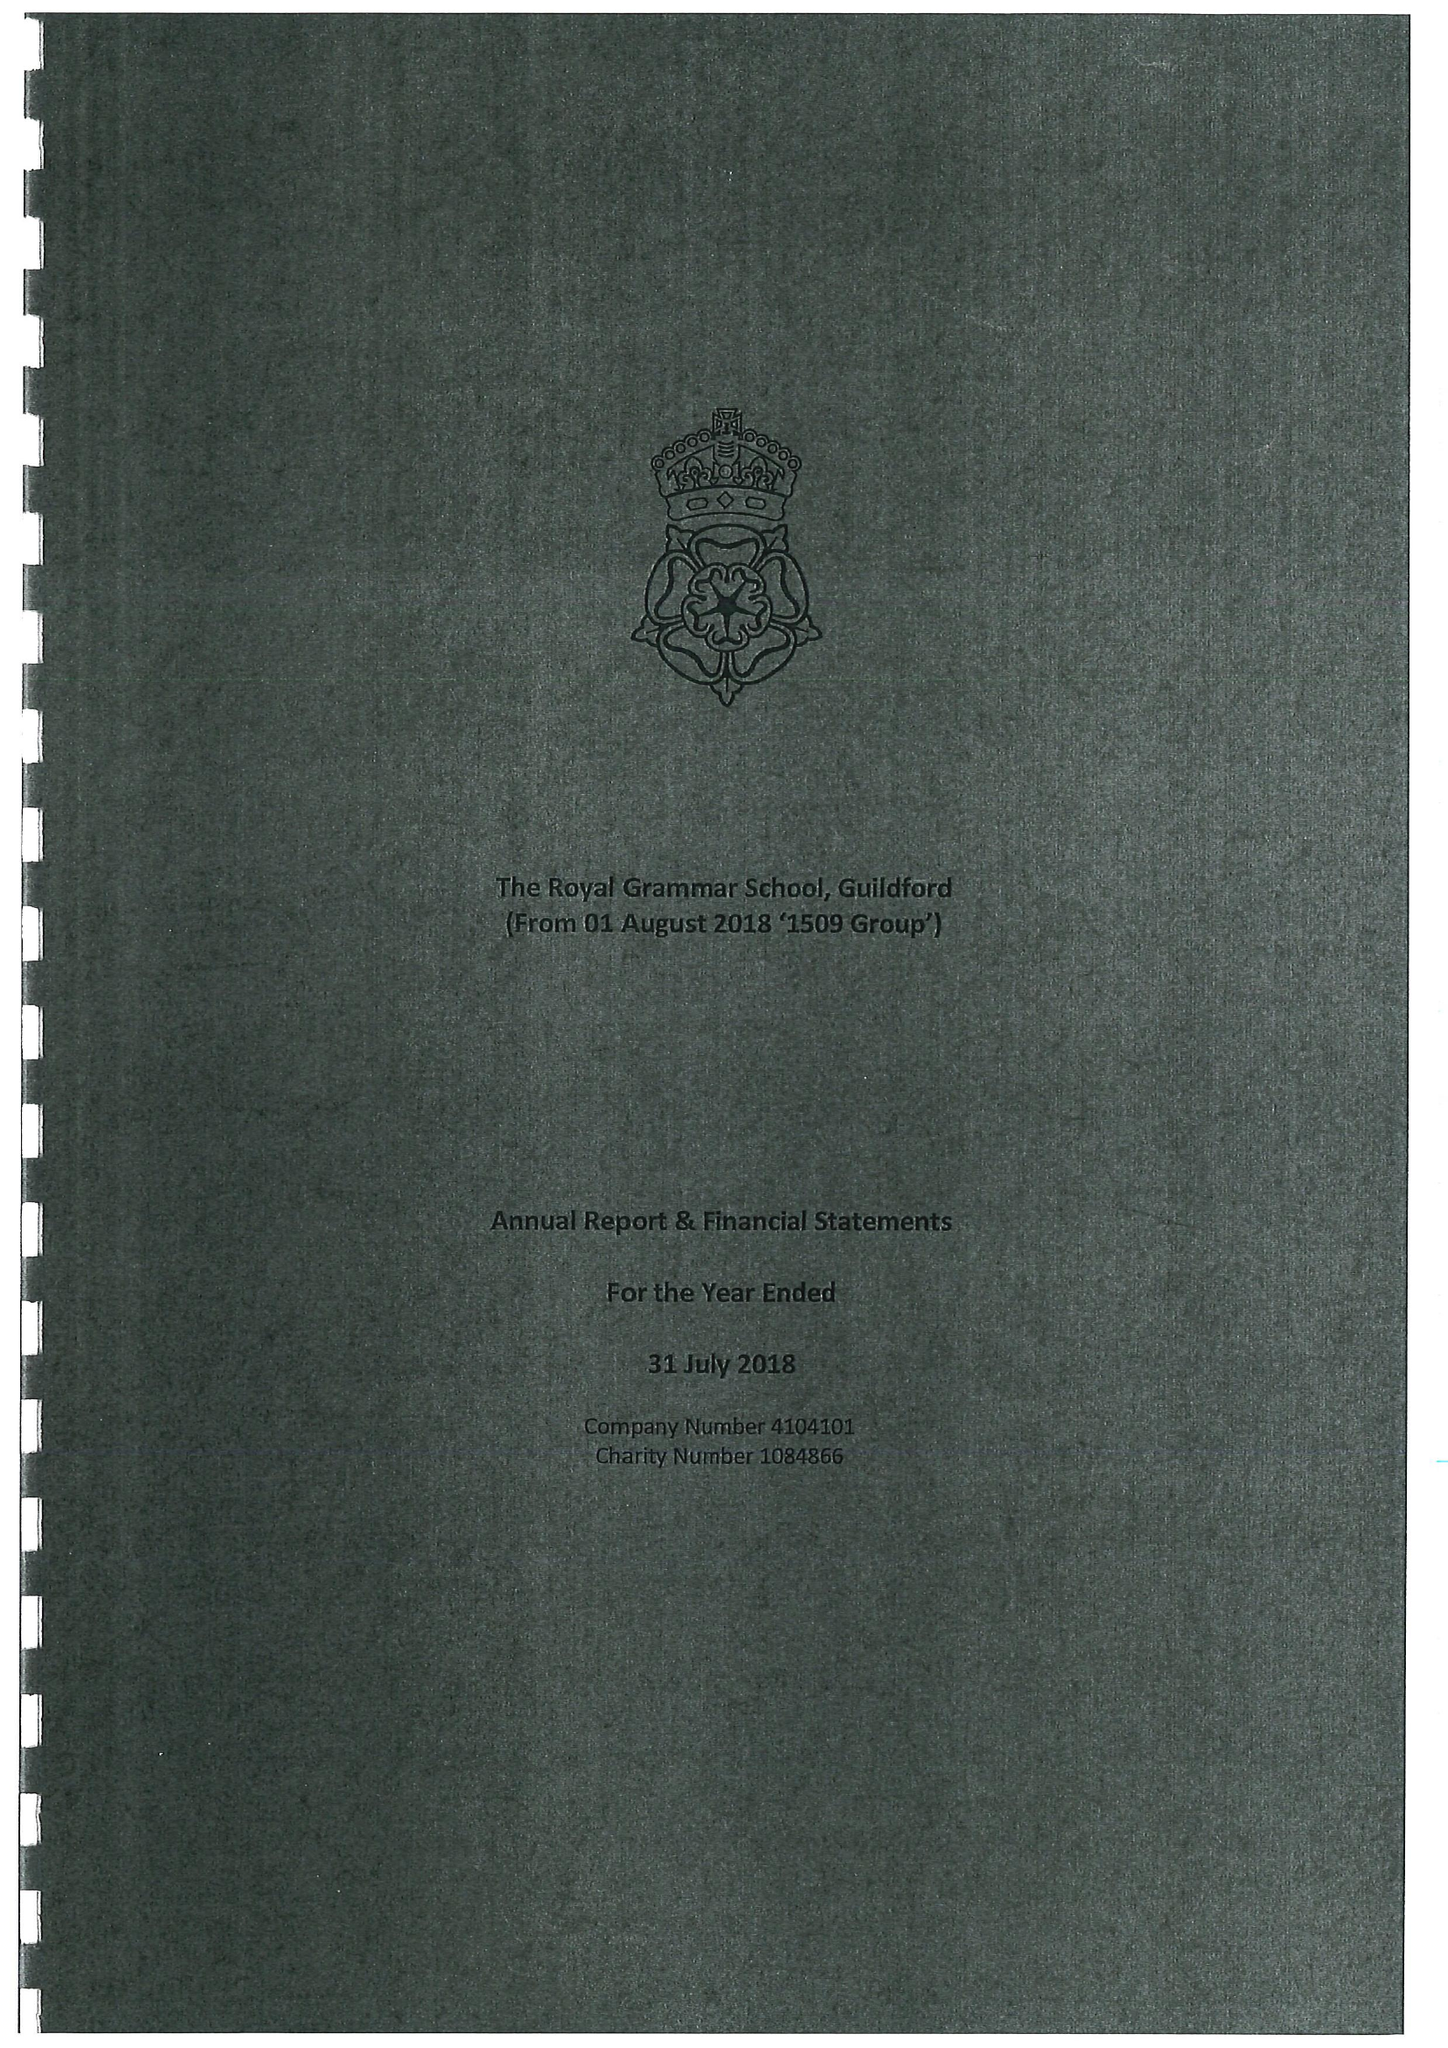What is the value for the charity_name?
Answer the question using a single word or phrase. The Royal Grammar School 